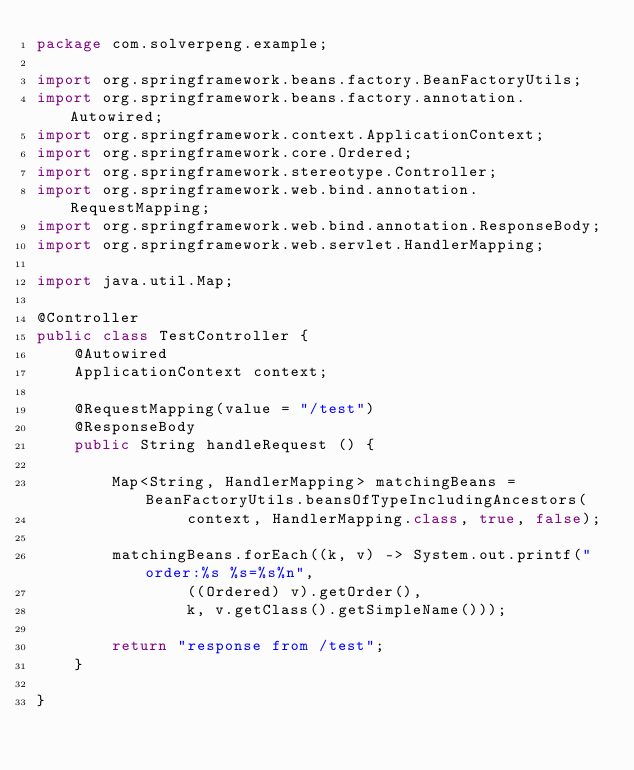<code> <loc_0><loc_0><loc_500><loc_500><_Java_>package com.solverpeng.example;

import org.springframework.beans.factory.BeanFactoryUtils;
import org.springframework.beans.factory.annotation.Autowired;
import org.springframework.context.ApplicationContext;
import org.springframework.core.Ordered;
import org.springframework.stereotype.Controller;
import org.springframework.web.bind.annotation.RequestMapping;
import org.springframework.web.bind.annotation.ResponseBody;
import org.springframework.web.servlet.HandlerMapping;

import java.util.Map;

@Controller
public class TestController {
    @Autowired
    ApplicationContext context;

    @RequestMapping(value = "/test")
    @ResponseBody
    public String handleRequest () {

        Map<String, HandlerMapping> matchingBeans = BeanFactoryUtils.beansOfTypeIncludingAncestors(
                context, HandlerMapping.class, true, false);

        matchingBeans.forEach((k, v) -> System.out.printf("order:%s %s=%s%n",
                ((Ordered) v).getOrder(),
                k, v.getClass().getSimpleName()));

        return "response from /test";
    }

}
</code> 